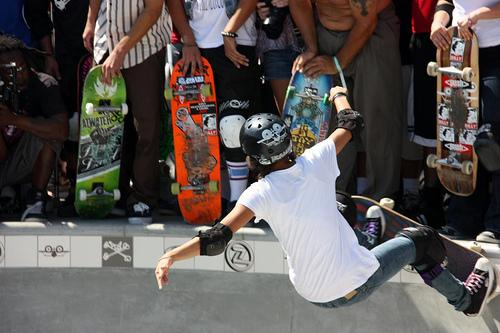Where did OG skateboarders develop this style of boarding? california 